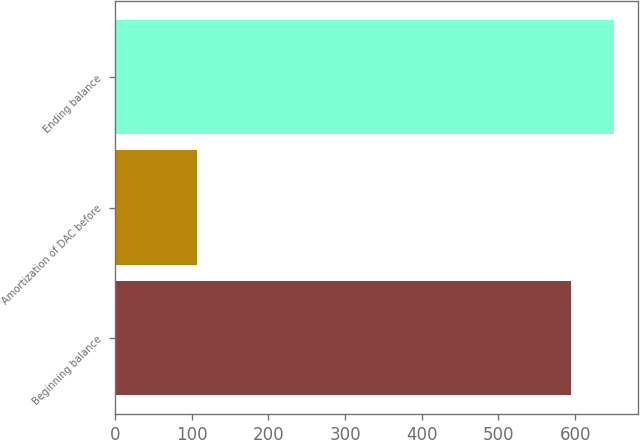<chart> <loc_0><loc_0><loc_500><loc_500><bar_chart><fcel>Beginning balance<fcel>Amortization of DAC before<fcel>Ending balance<nl><fcel>595<fcel>107<fcel>650<nl></chart> 